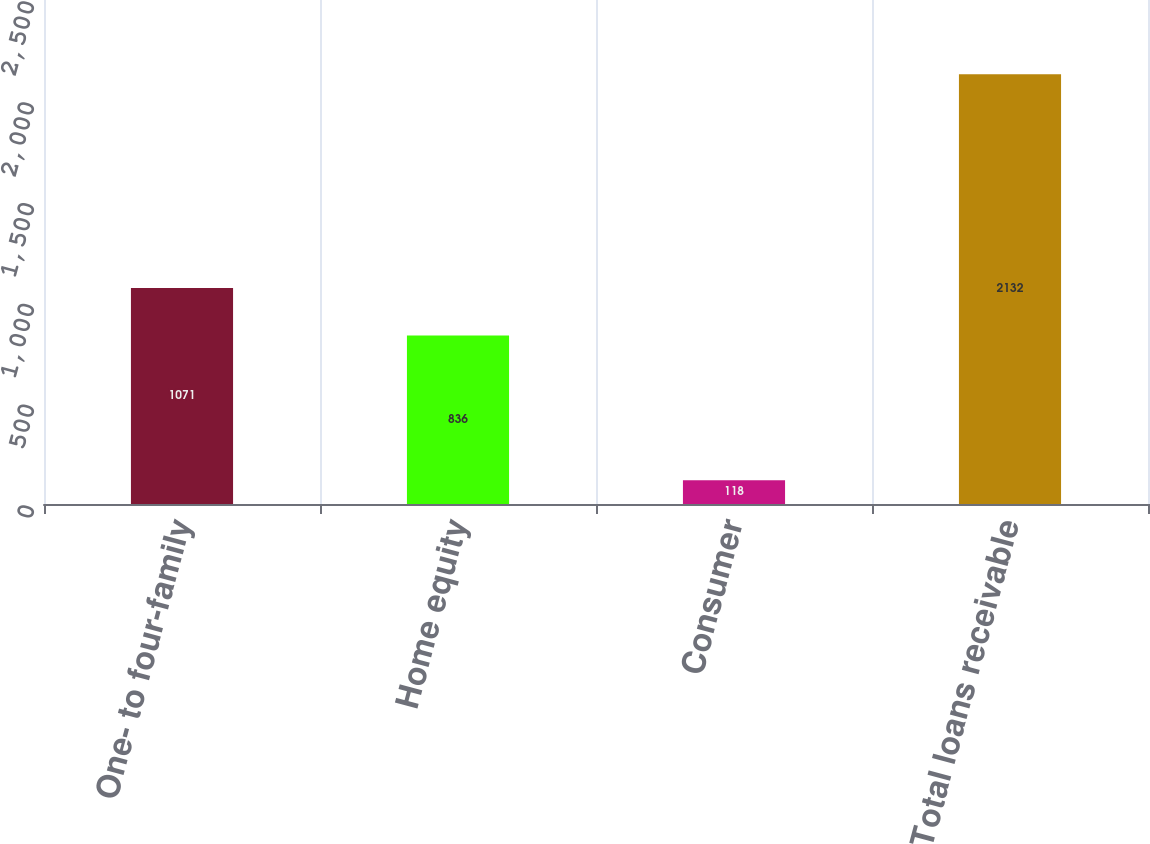Convert chart. <chart><loc_0><loc_0><loc_500><loc_500><bar_chart><fcel>One- to four-family<fcel>Home equity<fcel>Consumer<fcel>Total loans receivable<nl><fcel>1071<fcel>836<fcel>118<fcel>2132<nl></chart> 